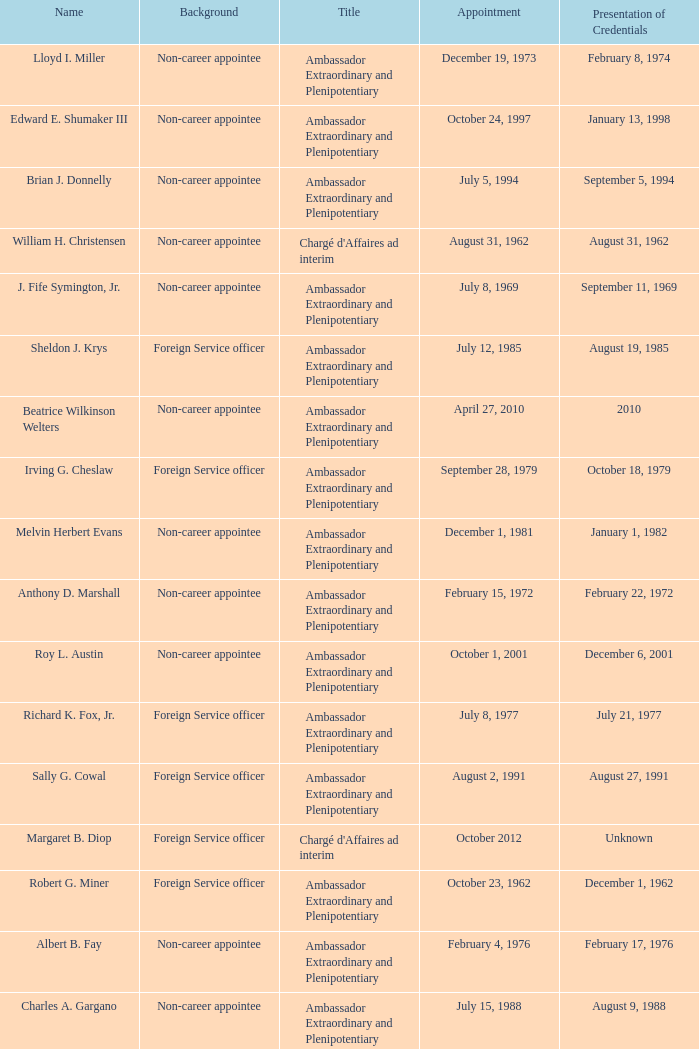When did Robert G. Miner present his credentials? December 1, 1962. 